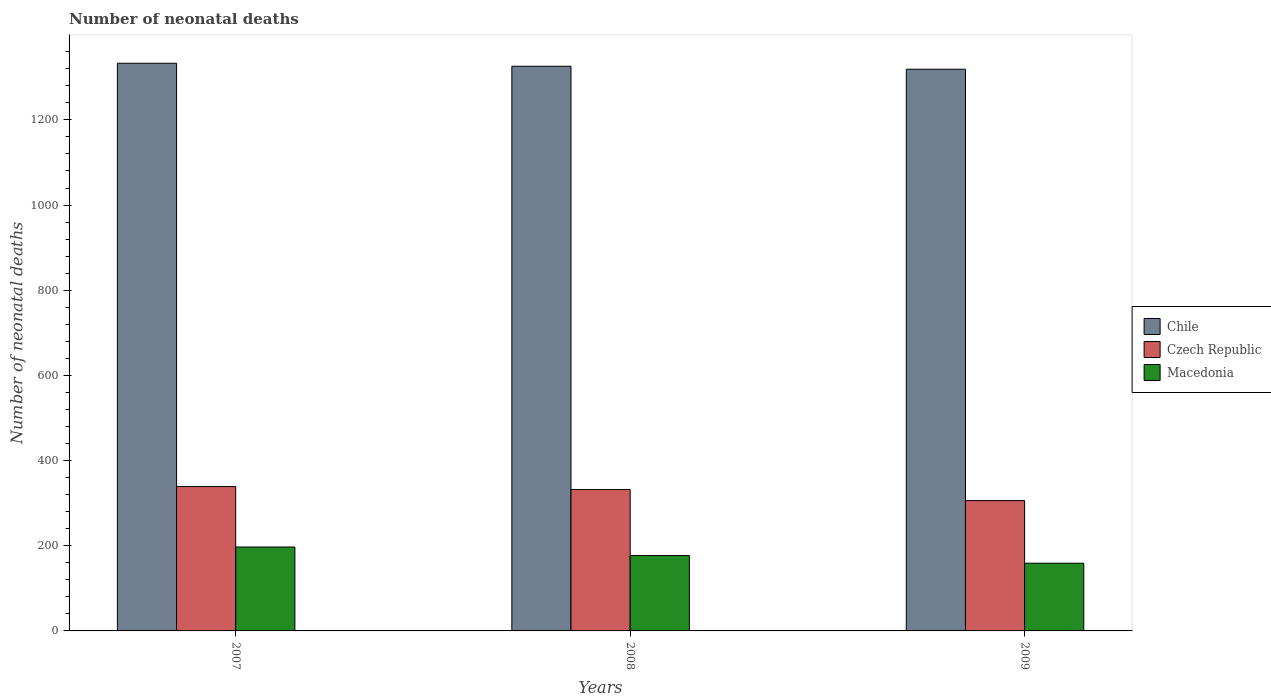How many different coloured bars are there?
Your answer should be compact. 3. How many groups of bars are there?
Ensure brevity in your answer.  3. Are the number of bars on each tick of the X-axis equal?
Your answer should be compact. Yes. How many bars are there on the 2nd tick from the left?
Keep it short and to the point. 3. What is the number of neonatal deaths in in Czech Republic in 2008?
Keep it short and to the point. 332. Across all years, what is the maximum number of neonatal deaths in in Macedonia?
Give a very brief answer. 197. Across all years, what is the minimum number of neonatal deaths in in Macedonia?
Ensure brevity in your answer.  159. In which year was the number of neonatal deaths in in Czech Republic minimum?
Your answer should be very brief. 2009. What is the total number of neonatal deaths in in Chile in the graph?
Offer a terse response. 3978. What is the difference between the number of neonatal deaths in in Chile in 2007 and that in 2008?
Provide a succinct answer. 7. What is the difference between the number of neonatal deaths in in Czech Republic in 2007 and the number of neonatal deaths in in Chile in 2009?
Ensure brevity in your answer.  -980. What is the average number of neonatal deaths in in Macedonia per year?
Your response must be concise. 177.67. In the year 2007, what is the difference between the number of neonatal deaths in in Czech Republic and number of neonatal deaths in in Chile?
Offer a very short reply. -994. What is the ratio of the number of neonatal deaths in in Macedonia in 2007 to that in 2009?
Keep it short and to the point. 1.24. Is the number of neonatal deaths in in Macedonia in 2007 less than that in 2008?
Make the answer very short. No. What is the difference between the highest and the second highest number of neonatal deaths in in Czech Republic?
Your response must be concise. 7. What is the difference between the highest and the lowest number of neonatal deaths in in Czech Republic?
Keep it short and to the point. 33. In how many years, is the number of neonatal deaths in in Chile greater than the average number of neonatal deaths in in Chile taken over all years?
Give a very brief answer. 1. Is the sum of the number of neonatal deaths in in Czech Republic in 2007 and 2008 greater than the maximum number of neonatal deaths in in Chile across all years?
Ensure brevity in your answer.  No. Are all the bars in the graph horizontal?
Give a very brief answer. No. What is the difference between two consecutive major ticks on the Y-axis?
Keep it short and to the point. 200. How many legend labels are there?
Provide a succinct answer. 3. How are the legend labels stacked?
Give a very brief answer. Vertical. What is the title of the graph?
Make the answer very short. Number of neonatal deaths. What is the label or title of the X-axis?
Provide a short and direct response. Years. What is the label or title of the Y-axis?
Provide a succinct answer. Number of neonatal deaths. What is the Number of neonatal deaths in Chile in 2007?
Provide a short and direct response. 1333. What is the Number of neonatal deaths in Czech Republic in 2007?
Provide a short and direct response. 339. What is the Number of neonatal deaths in Macedonia in 2007?
Your answer should be very brief. 197. What is the Number of neonatal deaths of Chile in 2008?
Your answer should be compact. 1326. What is the Number of neonatal deaths in Czech Republic in 2008?
Offer a terse response. 332. What is the Number of neonatal deaths of Macedonia in 2008?
Your response must be concise. 177. What is the Number of neonatal deaths in Chile in 2009?
Offer a very short reply. 1319. What is the Number of neonatal deaths in Czech Republic in 2009?
Provide a short and direct response. 306. What is the Number of neonatal deaths of Macedonia in 2009?
Your answer should be very brief. 159. Across all years, what is the maximum Number of neonatal deaths in Chile?
Keep it short and to the point. 1333. Across all years, what is the maximum Number of neonatal deaths of Czech Republic?
Offer a very short reply. 339. Across all years, what is the maximum Number of neonatal deaths of Macedonia?
Ensure brevity in your answer.  197. Across all years, what is the minimum Number of neonatal deaths of Chile?
Provide a succinct answer. 1319. Across all years, what is the minimum Number of neonatal deaths in Czech Republic?
Make the answer very short. 306. Across all years, what is the minimum Number of neonatal deaths of Macedonia?
Your answer should be very brief. 159. What is the total Number of neonatal deaths of Chile in the graph?
Ensure brevity in your answer.  3978. What is the total Number of neonatal deaths of Czech Republic in the graph?
Make the answer very short. 977. What is the total Number of neonatal deaths in Macedonia in the graph?
Provide a succinct answer. 533. What is the difference between the Number of neonatal deaths in Chile in 2007 and that in 2008?
Provide a succinct answer. 7. What is the difference between the Number of neonatal deaths in Czech Republic in 2007 and that in 2008?
Your answer should be very brief. 7. What is the difference between the Number of neonatal deaths of Macedonia in 2007 and that in 2008?
Your response must be concise. 20. What is the difference between the Number of neonatal deaths of Chile in 2007 and that in 2009?
Keep it short and to the point. 14. What is the difference between the Number of neonatal deaths of Macedonia in 2007 and that in 2009?
Offer a very short reply. 38. What is the difference between the Number of neonatal deaths in Chile in 2008 and that in 2009?
Provide a succinct answer. 7. What is the difference between the Number of neonatal deaths of Czech Republic in 2008 and that in 2009?
Provide a succinct answer. 26. What is the difference between the Number of neonatal deaths in Chile in 2007 and the Number of neonatal deaths in Czech Republic in 2008?
Keep it short and to the point. 1001. What is the difference between the Number of neonatal deaths of Chile in 2007 and the Number of neonatal deaths of Macedonia in 2008?
Your answer should be compact. 1156. What is the difference between the Number of neonatal deaths in Czech Republic in 2007 and the Number of neonatal deaths in Macedonia in 2008?
Your answer should be very brief. 162. What is the difference between the Number of neonatal deaths in Chile in 2007 and the Number of neonatal deaths in Czech Republic in 2009?
Offer a very short reply. 1027. What is the difference between the Number of neonatal deaths in Chile in 2007 and the Number of neonatal deaths in Macedonia in 2009?
Offer a terse response. 1174. What is the difference between the Number of neonatal deaths of Czech Republic in 2007 and the Number of neonatal deaths of Macedonia in 2009?
Ensure brevity in your answer.  180. What is the difference between the Number of neonatal deaths in Chile in 2008 and the Number of neonatal deaths in Czech Republic in 2009?
Keep it short and to the point. 1020. What is the difference between the Number of neonatal deaths of Chile in 2008 and the Number of neonatal deaths of Macedonia in 2009?
Offer a very short reply. 1167. What is the difference between the Number of neonatal deaths of Czech Republic in 2008 and the Number of neonatal deaths of Macedonia in 2009?
Provide a short and direct response. 173. What is the average Number of neonatal deaths in Chile per year?
Offer a very short reply. 1326. What is the average Number of neonatal deaths of Czech Republic per year?
Offer a terse response. 325.67. What is the average Number of neonatal deaths in Macedonia per year?
Provide a succinct answer. 177.67. In the year 2007, what is the difference between the Number of neonatal deaths in Chile and Number of neonatal deaths in Czech Republic?
Provide a short and direct response. 994. In the year 2007, what is the difference between the Number of neonatal deaths of Chile and Number of neonatal deaths of Macedonia?
Your response must be concise. 1136. In the year 2007, what is the difference between the Number of neonatal deaths of Czech Republic and Number of neonatal deaths of Macedonia?
Make the answer very short. 142. In the year 2008, what is the difference between the Number of neonatal deaths in Chile and Number of neonatal deaths in Czech Republic?
Your response must be concise. 994. In the year 2008, what is the difference between the Number of neonatal deaths in Chile and Number of neonatal deaths in Macedonia?
Make the answer very short. 1149. In the year 2008, what is the difference between the Number of neonatal deaths in Czech Republic and Number of neonatal deaths in Macedonia?
Your answer should be very brief. 155. In the year 2009, what is the difference between the Number of neonatal deaths of Chile and Number of neonatal deaths of Czech Republic?
Offer a terse response. 1013. In the year 2009, what is the difference between the Number of neonatal deaths in Chile and Number of neonatal deaths in Macedonia?
Ensure brevity in your answer.  1160. In the year 2009, what is the difference between the Number of neonatal deaths in Czech Republic and Number of neonatal deaths in Macedonia?
Your answer should be very brief. 147. What is the ratio of the Number of neonatal deaths of Chile in 2007 to that in 2008?
Your answer should be compact. 1.01. What is the ratio of the Number of neonatal deaths of Czech Republic in 2007 to that in 2008?
Provide a short and direct response. 1.02. What is the ratio of the Number of neonatal deaths in Macedonia in 2007 to that in 2008?
Your response must be concise. 1.11. What is the ratio of the Number of neonatal deaths of Chile in 2007 to that in 2009?
Ensure brevity in your answer.  1.01. What is the ratio of the Number of neonatal deaths of Czech Republic in 2007 to that in 2009?
Ensure brevity in your answer.  1.11. What is the ratio of the Number of neonatal deaths of Macedonia in 2007 to that in 2009?
Ensure brevity in your answer.  1.24. What is the ratio of the Number of neonatal deaths of Czech Republic in 2008 to that in 2009?
Ensure brevity in your answer.  1.08. What is the ratio of the Number of neonatal deaths of Macedonia in 2008 to that in 2009?
Provide a succinct answer. 1.11. What is the difference between the highest and the second highest Number of neonatal deaths in Chile?
Give a very brief answer. 7. What is the difference between the highest and the second highest Number of neonatal deaths in Macedonia?
Your response must be concise. 20. What is the difference between the highest and the lowest Number of neonatal deaths in Czech Republic?
Your response must be concise. 33. What is the difference between the highest and the lowest Number of neonatal deaths in Macedonia?
Offer a terse response. 38. 